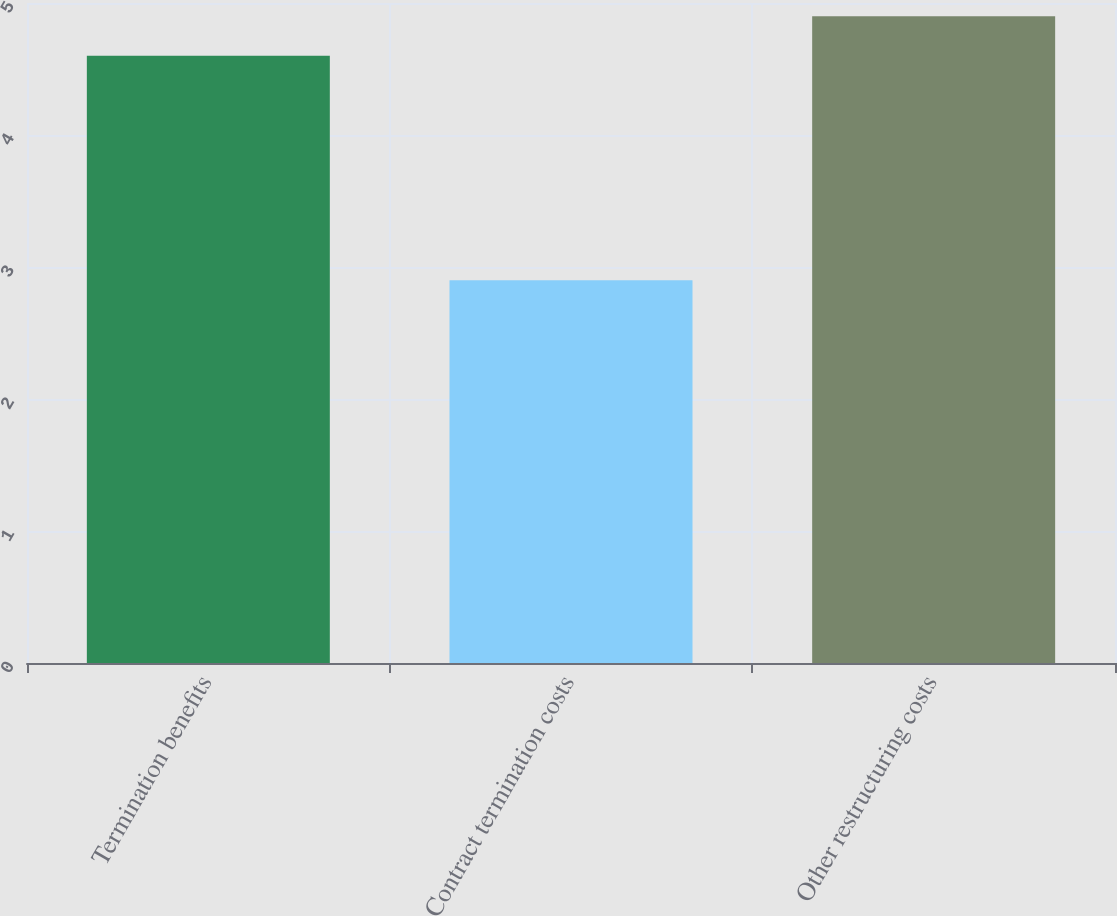<chart> <loc_0><loc_0><loc_500><loc_500><bar_chart><fcel>Termination benefits<fcel>Contract termination costs<fcel>Other restructuring costs<nl><fcel>4.6<fcel>2.9<fcel>4.9<nl></chart> 